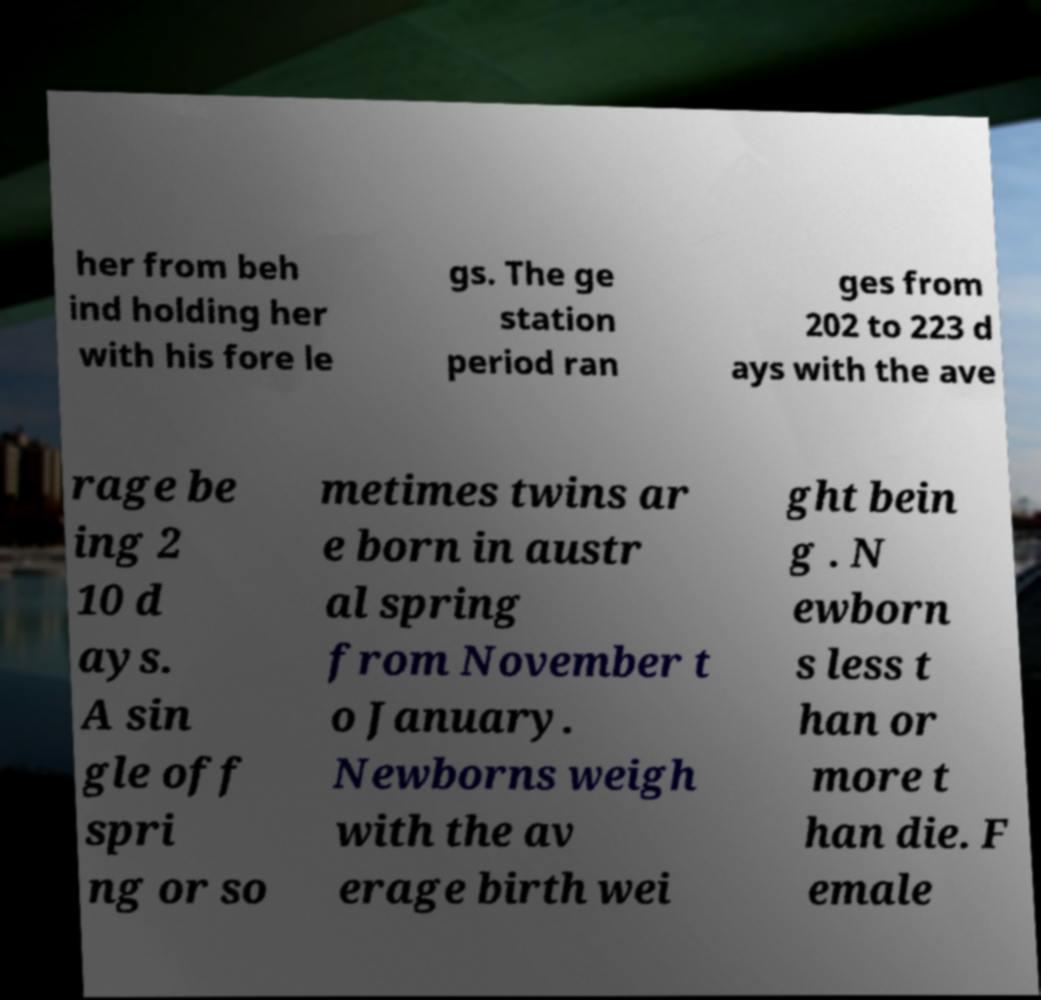There's text embedded in this image that I need extracted. Can you transcribe it verbatim? her from beh ind holding her with his fore le gs. The ge station period ran ges from 202 to 223 d ays with the ave rage be ing 2 10 d ays. A sin gle off spri ng or so metimes twins ar e born in austr al spring from November t o January. Newborns weigh with the av erage birth wei ght bein g . N ewborn s less t han or more t han die. F emale 